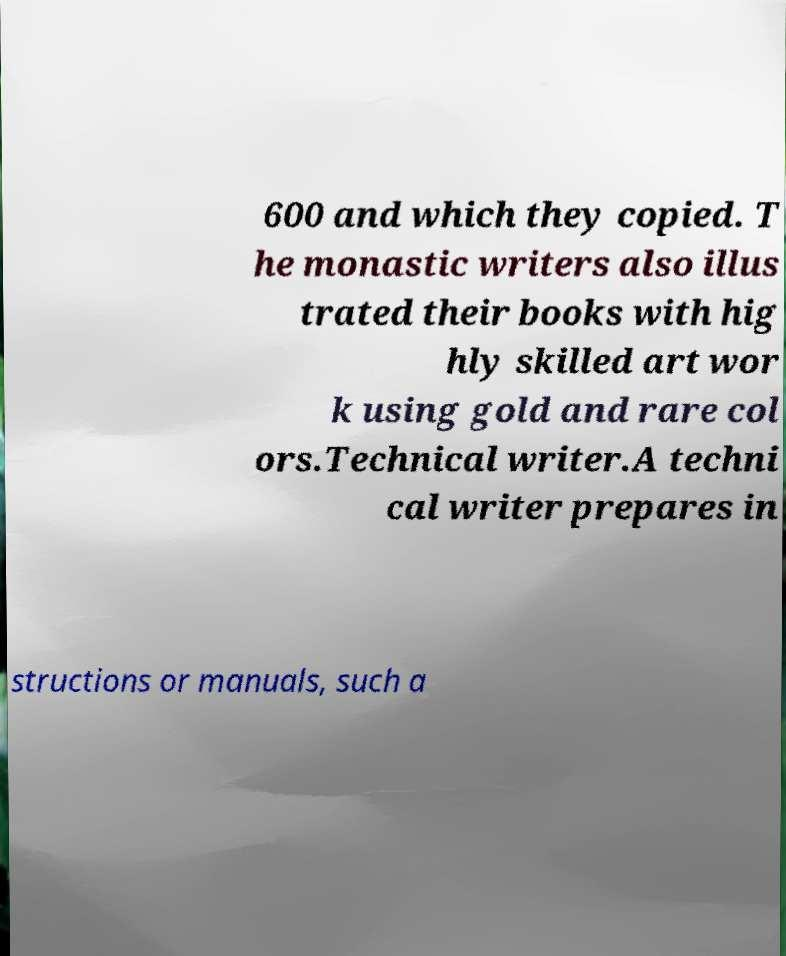Could you assist in decoding the text presented in this image and type it out clearly? 600 and which they copied. T he monastic writers also illus trated their books with hig hly skilled art wor k using gold and rare col ors.Technical writer.A techni cal writer prepares in structions or manuals, such a 